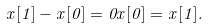<formula> <loc_0><loc_0><loc_500><loc_500>x [ 1 ] - x [ 0 ] = 0 x [ 0 ] = x [ 1 ] .</formula> 